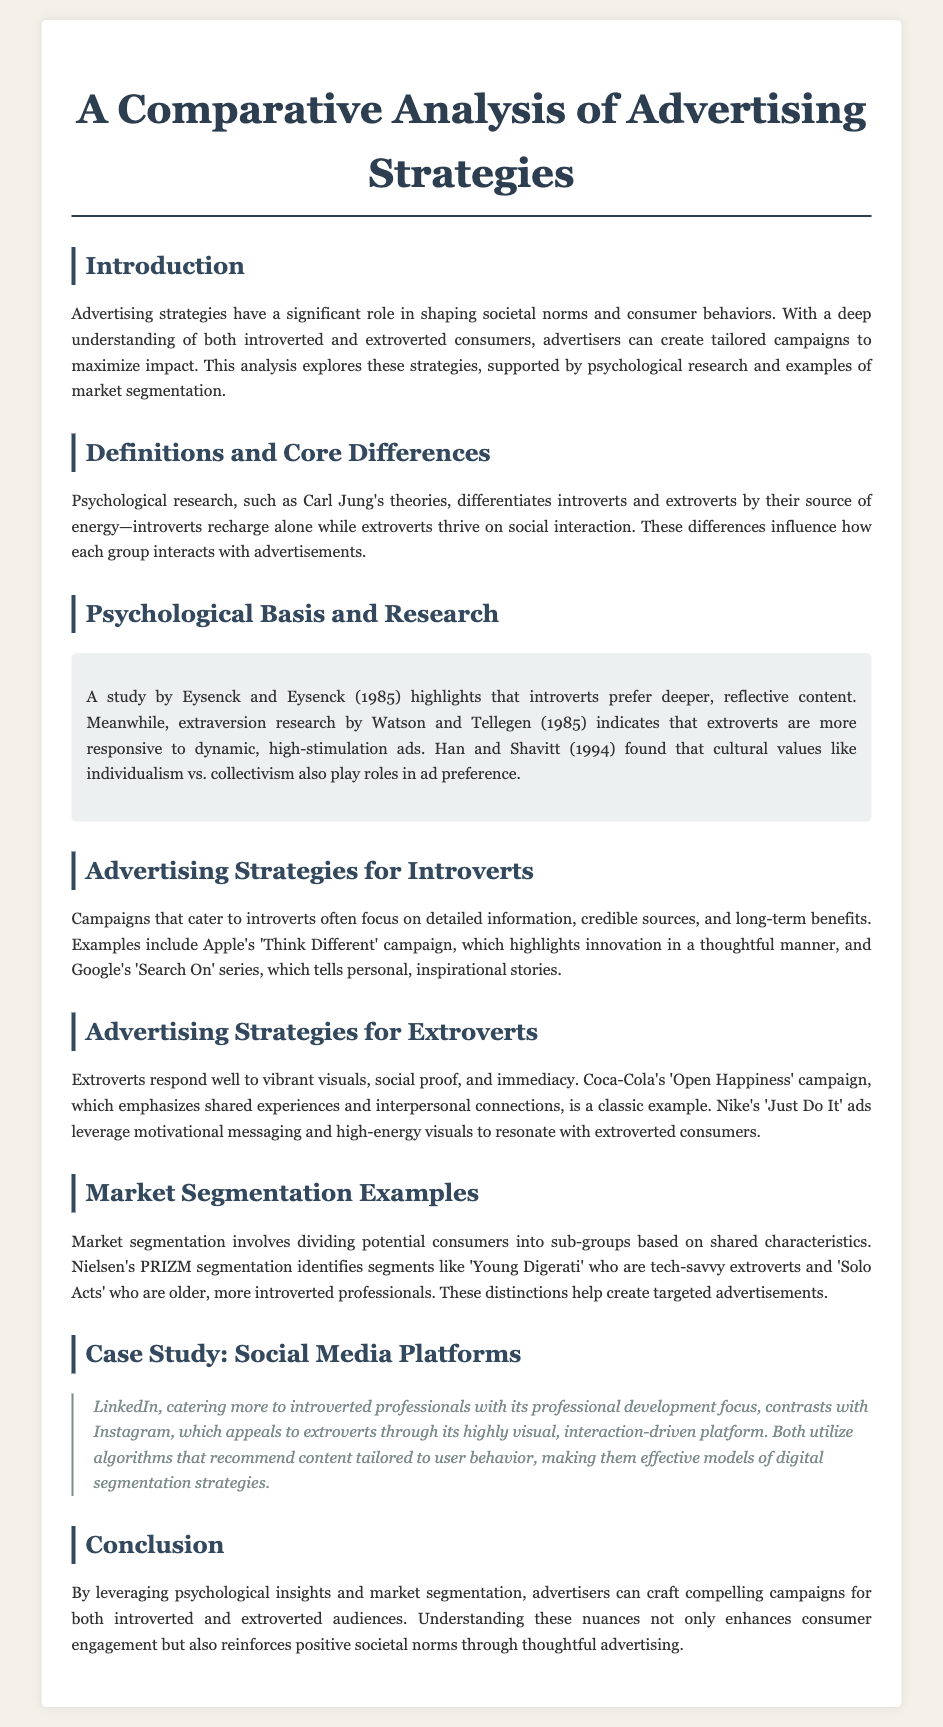What are the two consumer types discussed? The document discusses introverted and extroverted consumers as the two consumer types.
Answer: introverted and extroverted Which psychological theory differentiates introverts and extroverts? The theory of differentiation comes from Carl Jung's theories mentioned in the document.
Answer: Carl Jung's theories What type of content do introverts prefer in advertisements? The document mentions that introverts prefer deeper, reflective content according to the study by Eysenck and Eysenck.
Answer: deeper, reflective content Name an example of a campaign targeting introverts. The document cites Apple's 'Think Different' campaign as an example of targeting introverts.
Answer: Apple's 'Think Different' What is the main focus of LinkedIn according to the case study? The document states that LinkedIn caters more to introverted professionals with a focus on professional development.
Answer: professional development Which market segmentation example is mentioned in the document? The document references Nielsen's PRIZM segmentation as a market segmentation example.
Answer: Nielsen's PRIZM segmentation How do extroverts generally respond to advertising content? The document states that extroverts respond well to vibrant visuals, social proof, and immediacy.
Answer: vibrant visuals, social proof, and immediacy What advertising campaign emphasizes shared experiences? The document mentions Coca-Cola's 'Open Happiness' as the campaign emphasizing shared experiences.
Answer: Coca-Cola's 'Open Happiness' Which platforms are contrasted in the case study? The document contrasts LinkedIn and Instagram in terms of their target audiences.
Answer: LinkedIn and Instagram 